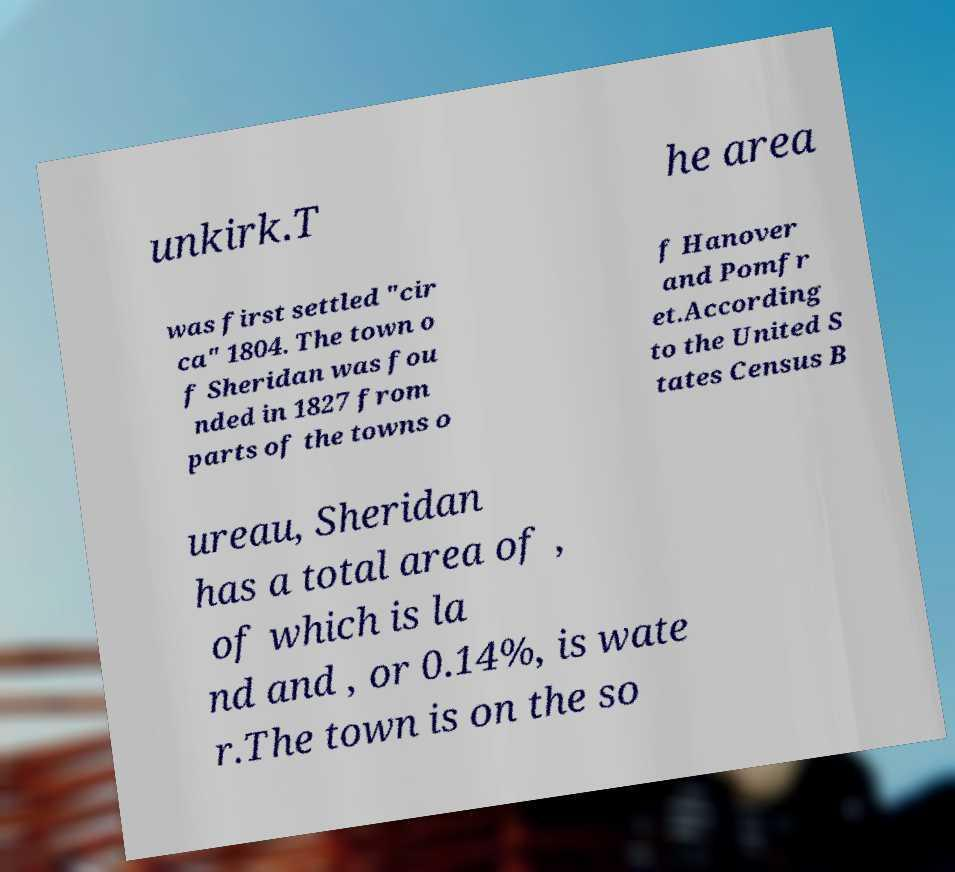I need the written content from this picture converted into text. Can you do that? unkirk.T he area was first settled "cir ca" 1804. The town o f Sheridan was fou nded in 1827 from parts of the towns o f Hanover and Pomfr et.According to the United S tates Census B ureau, Sheridan has a total area of , of which is la nd and , or 0.14%, is wate r.The town is on the so 